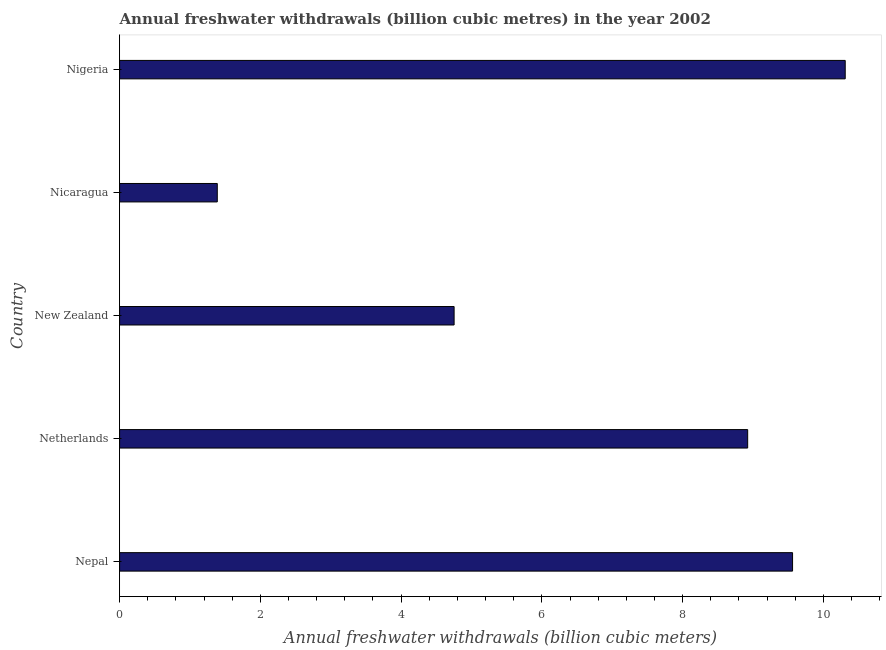What is the title of the graph?
Offer a very short reply. Annual freshwater withdrawals (billion cubic metres) in the year 2002. What is the label or title of the X-axis?
Give a very brief answer. Annual freshwater withdrawals (billion cubic meters). What is the label or title of the Y-axis?
Your response must be concise. Country. What is the annual freshwater withdrawals in Netherlands?
Your answer should be very brief. 8.92. Across all countries, what is the maximum annual freshwater withdrawals?
Your answer should be very brief. 10.31. Across all countries, what is the minimum annual freshwater withdrawals?
Your answer should be compact. 1.39. In which country was the annual freshwater withdrawals maximum?
Ensure brevity in your answer.  Nigeria. In which country was the annual freshwater withdrawals minimum?
Offer a terse response. Nicaragua. What is the sum of the annual freshwater withdrawals?
Your answer should be very brief. 34.94. What is the difference between the annual freshwater withdrawals in Nepal and Nigeria?
Provide a short and direct response. -0.75. What is the average annual freshwater withdrawals per country?
Your answer should be compact. 6.99. What is the median annual freshwater withdrawals?
Your response must be concise. 8.92. What is the ratio of the annual freshwater withdrawals in Nepal to that in Nigeria?
Provide a short and direct response. 0.93. Is the difference between the annual freshwater withdrawals in Nepal and Nicaragua greater than the difference between any two countries?
Make the answer very short. No. What is the difference between the highest and the second highest annual freshwater withdrawals?
Your response must be concise. 0.75. Is the sum of the annual freshwater withdrawals in Netherlands and Nicaragua greater than the maximum annual freshwater withdrawals across all countries?
Offer a terse response. Yes. What is the difference between the highest and the lowest annual freshwater withdrawals?
Your answer should be compact. 8.92. In how many countries, is the annual freshwater withdrawals greater than the average annual freshwater withdrawals taken over all countries?
Provide a short and direct response. 3. How many bars are there?
Provide a short and direct response. 5. What is the difference between two consecutive major ticks on the X-axis?
Ensure brevity in your answer.  2. Are the values on the major ticks of X-axis written in scientific E-notation?
Your answer should be compact. No. What is the Annual freshwater withdrawals (billion cubic meters) of Nepal?
Offer a very short reply. 9.56. What is the Annual freshwater withdrawals (billion cubic meters) of Netherlands?
Your answer should be compact. 8.92. What is the Annual freshwater withdrawals (billion cubic meters) of New Zealand?
Your answer should be very brief. 4.75. What is the Annual freshwater withdrawals (billion cubic meters) in Nicaragua?
Keep it short and to the point. 1.39. What is the Annual freshwater withdrawals (billion cubic meters) of Nigeria?
Offer a very short reply. 10.31. What is the difference between the Annual freshwater withdrawals (billion cubic meters) in Nepal and Netherlands?
Your answer should be compact. 0.64. What is the difference between the Annual freshwater withdrawals (billion cubic meters) in Nepal and New Zealand?
Your answer should be very brief. 4.81. What is the difference between the Annual freshwater withdrawals (billion cubic meters) in Nepal and Nicaragua?
Give a very brief answer. 8.17. What is the difference between the Annual freshwater withdrawals (billion cubic meters) in Nepal and Nigeria?
Offer a very short reply. -0.75. What is the difference between the Annual freshwater withdrawals (billion cubic meters) in Netherlands and New Zealand?
Provide a short and direct response. 4.17. What is the difference between the Annual freshwater withdrawals (billion cubic meters) in Netherlands and Nicaragua?
Give a very brief answer. 7.54. What is the difference between the Annual freshwater withdrawals (billion cubic meters) in Netherlands and Nigeria?
Offer a terse response. -1.39. What is the difference between the Annual freshwater withdrawals (billion cubic meters) in New Zealand and Nicaragua?
Make the answer very short. 3.37. What is the difference between the Annual freshwater withdrawals (billion cubic meters) in New Zealand and Nigeria?
Ensure brevity in your answer.  -5.56. What is the difference between the Annual freshwater withdrawals (billion cubic meters) in Nicaragua and Nigeria?
Your response must be concise. -8.92. What is the ratio of the Annual freshwater withdrawals (billion cubic meters) in Nepal to that in Netherlands?
Keep it short and to the point. 1.07. What is the ratio of the Annual freshwater withdrawals (billion cubic meters) in Nepal to that in New Zealand?
Provide a short and direct response. 2.01. What is the ratio of the Annual freshwater withdrawals (billion cubic meters) in Nepal to that in Nicaragua?
Keep it short and to the point. 6.89. What is the ratio of the Annual freshwater withdrawals (billion cubic meters) in Nepal to that in Nigeria?
Your answer should be compact. 0.93. What is the ratio of the Annual freshwater withdrawals (billion cubic meters) in Netherlands to that in New Zealand?
Ensure brevity in your answer.  1.88. What is the ratio of the Annual freshwater withdrawals (billion cubic meters) in Netherlands to that in Nicaragua?
Provide a short and direct response. 6.43. What is the ratio of the Annual freshwater withdrawals (billion cubic meters) in Netherlands to that in Nigeria?
Make the answer very short. 0.87. What is the ratio of the Annual freshwater withdrawals (billion cubic meters) in New Zealand to that in Nicaragua?
Provide a succinct answer. 3.42. What is the ratio of the Annual freshwater withdrawals (billion cubic meters) in New Zealand to that in Nigeria?
Offer a very short reply. 0.46. What is the ratio of the Annual freshwater withdrawals (billion cubic meters) in Nicaragua to that in Nigeria?
Keep it short and to the point. 0.14. 